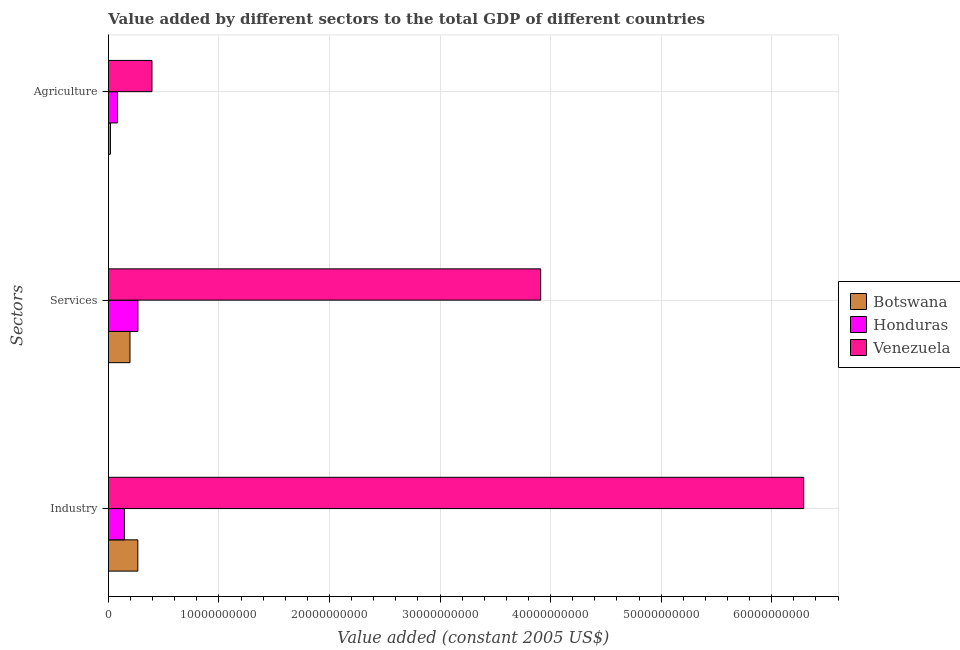How many different coloured bars are there?
Ensure brevity in your answer.  3. How many bars are there on the 2nd tick from the top?
Offer a terse response. 3. How many bars are there on the 3rd tick from the bottom?
Give a very brief answer. 3. What is the label of the 2nd group of bars from the top?
Provide a short and direct response. Services. What is the value added by services in Honduras?
Your response must be concise. 2.67e+09. Across all countries, what is the maximum value added by industrial sector?
Give a very brief answer. 6.29e+1. Across all countries, what is the minimum value added by services?
Ensure brevity in your answer.  1.95e+09. In which country was the value added by industrial sector maximum?
Your answer should be very brief. Venezuela. In which country was the value added by agricultural sector minimum?
Give a very brief answer. Botswana. What is the total value added by services in the graph?
Offer a very short reply. 4.37e+1. What is the difference between the value added by industrial sector in Venezuela and that in Botswana?
Your response must be concise. 6.02e+1. What is the difference between the value added by agricultural sector in Honduras and the value added by services in Venezuela?
Offer a terse response. -3.83e+1. What is the average value added by industrial sector per country?
Give a very brief answer. 2.23e+1. What is the difference between the value added by services and value added by industrial sector in Venezuela?
Provide a succinct answer. -2.38e+1. In how many countries, is the value added by services greater than 2000000000 US$?
Ensure brevity in your answer.  2. What is the ratio of the value added by industrial sector in Venezuela to that in Honduras?
Keep it short and to the point. 43.49. Is the value added by industrial sector in Botswana less than that in Venezuela?
Make the answer very short. Yes. What is the difference between the highest and the second highest value added by agricultural sector?
Provide a succinct answer. 3.12e+09. What is the difference between the highest and the lowest value added by agricultural sector?
Offer a terse response. 3.76e+09. Is the sum of the value added by services in Honduras and Venezuela greater than the maximum value added by agricultural sector across all countries?
Give a very brief answer. Yes. What does the 2nd bar from the top in Services represents?
Provide a succinct answer. Honduras. What does the 1st bar from the bottom in Industry represents?
Your answer should be very brief. Botswana. Are all the bars in the graph horizontal?
Provide a succinct answer. Yes. How many countries are there in the graph?
Give a very brief answer. 3. What is the difference between two consecutive major ticks on the X-axis?
Provide a short and direct response. 1.00e+1. Does the graph contain any zero values?
Your response must be concise. No. How many legend labels are there?
Your answer should be compact. 3. How are the legend labels stacked?
Keep it short and to the point. Vertical. What is the title of the graph?
Keep it short and to the point. Value added by different sectors to the total GDP of different countries. Does "Mongolia" appear as one of the legend labels in the graph?
Give a very brief answer. No. What is the label or title of the X-axis?
Keep it short and to the point. Value added (constant 2005 US$). What is the label or title of the Y-axis?
Your response must be concise. Sectors. What is the Value added (constant 2005 US$) in Botswana in Industry?
Your answer should be compact. 2.66e+09. What is the Value added (constant 2005 US$) of Honduras in Industry?
Your response must be concise. 1.45e+09. What is the Value added (constant 2005 US$) in Venezuela in Industry?
Give a very brief answer. 6.29e+1. What is the Value added (constant 2005 US$) of Botswana in Services?
Keep it short and to the point. 1.95e+09. What is the Value added (constant 2005 US$) of Honduras in Services?
Your answer should be compact. 2.67e+09. What is the Value added (constant 2005 US$) of Venezuela in Services?
Offer a very short reply. 3.91e+1. What is the Value added (constant 2005 US$) in Botswana in Agriculture?
Offer a very short reply. 1.83e+08. What is the Value added (constant 2005 US$) in Honduras in Agriculture?
Offer a terse response. 8.21e+08. What is the Value added (constant 2005 US$) in Venezuela in Agriculture?
Provide a short and direct response. 3.94e+09. Across all Sectors, what is the maximum Value added (constant 2005 US$) of Botswana?
Your answer should be compact. 2.66e+09. Across all Sectors, what is the maximum Value added (constant 2005 US$) of Honduras?
Offer a terse response. 2.67e+09. Across all Sectors, what is the maximum Value added (constant 2005 US$) in Venezuela?
Keep it short and to the point. 6.29e+1. Across all Sectors, what is the minimum Value added (constant 2005 US$) in Botswana?
Make the answer very short. 1.83e+08. Across all Sectors, what is the minimum Value added (constant 2005 US$) of Honduras?
Give a very brief answer. 8.21e+08. Across all Sectors, what is the minimum Value added (constant 2005 US$) in Venezuela?
Give a very brief answer. 3.94e+09. What is the total Value added (constant 2005 US$) of Botswana in the graph?
Provide a succinct answer. 4.79e+09. What is the total Value added (constant 2005 US$) in Honduras in the graph?
Offer a very short reply. 4.94e+09. What is the total Value added (constant 2005 US$) in Venezuela in the graph?
Your response must be concise. 1.06e+11. What is the difference between the Value added (constant 2005 US$) of Botswana in Industry and that in Services?
Give a very brief answer. 7.10e+08. What is the difference between the Value added (constant 2005 US$) in Honduras in Industry and that in Services?
Provide a short and direct response. -1.22e+09. What is the difference between the Value added (constant 2005 US$) in Venezuela in Industry and that in Services?
Give a very brief answer. 2.38e+1. What is the difference between the Value added (constant 2005 US$) of Botswana in Industry and that in Agriculture?
Your answer should be very brief. 2.48e+09. What is the difference between the Value added (constant 2005 US$) of Honduras in Industry and that in Agriculture?
Your answer should be very brief. 6.25e+08. What is the difference between the Value added (constant 2005 US$) of Venezuela in Industry and that in Agriculture?
Offer a very short reply. 5.90e+1. What is the difference between the Value added (constant 2005 US$) in Botswana in Services and that in Agriculture?
Your answer should be compact. 1.77e+09. What is the difference between the Value added (constant 2005 US$) of Honduras in Services and that in Agriculture?
Your answer should be compact. 1.85e+09. What is the difference between the Value added (constant 2005 US$) of Venezuela in Services and that in Agriculture?
Offer a very short reply. 3.52e+1. What is the difference between the Value added (constant 2005 US$) in Botswana in Industry and the Value added (constant 2005 US$) in Honduras in Services?
Offer a terse response. -8.78e+06. What is the difference between the Value added (constant 2005 US$) of Botswana in Industry and the Value added (constant 2005 US$) of Venezuela in Services?
Your answer should be compact. -3.64e+1. What is the difference between the Value added (constant 2005 US$) in Honduras in Industry and the Value added (constant 2005 US$) in Venezuela in Services?
Your answer should be compact. -3.77e+1. What is the difference between the Value added (constant 2005 US$) of Botswana in Industry and the Value added (constant 2005 US$) of Honduras in Agriculture?
Offer a terse response. 1.84e+09. What is the difference between the Value added (constant 2005 US$) in Botswana in Industry and the Value added (constant 2005 US$) in Venezuela in Agriculture?
Your answer should be compact. -1.28e+09. What is the difference between the Value added (constant 2005 US$) in Honduras in Industry and the Value added (constant 2005 US$) in Venezuela in Agriculture?
Ensure brevity in your answer.  -2.49e+09. What is the difference between the Value added (constant 2005 US$) in Botswana in Services and the Value added (constant 2005 US$) in Honduras in Agriculture?
Keep it short and to the point. 1.13e+09. What is the difference between the Value added (constant 2005 US$) in Botswana in Services and the Value added (constant 2005 US$) in Venezuela in Agriculture?
Your response must be concise. -1.99e+09. What is the difference between the Value added (constant 2005 US$) of Honduras in Services and the Value added (constant 2005 US$) of Venezuela in Agriculture?
Keep it short and to the point. -1.27e+09. What is the average Value added (constant 2005 US$) in Botswana per Sectors?
Make the answer very short. 1.60e+09. What is the average Value added (constant 2005 US$) in Honduras per Sectors?
Provide a succinct answer. 1.65e+09. What is the average Value added (constant 2005 US$) of Venezuela per Sectors?
Ensure brevity in your answer.  3.53e+1. What is the difference between the Value added (constant 2005 US$) in Botswana and Value added (constant 2005 US$) in Honduras in Industry?
Provide a succinct answer. 1.21e+09. What is the difference between the Value added (constant 2005 US$) in Botswana and Value added (constant 2005 US$) in Venezuela in Industry?
Offer a terse response. -6.02e+1. What is the difference between the Value added (constant 2005 US$) in Honduras and Value added (constant 2005 US$) in Venezuela in Industry?
Your answer should be compact. -6.14e+1. What is the difference between the Value added (constant 2005 US$) in Botswana and Value added (constant 2005 US$) in Honduras in Services?
Give a very brief answer. -7.19e+08. What is the difference between the Value added (constant 2005 US$) of Botswana and Value added (constant 2005 US$) of Venezuela in Services?
Keep it short and to the point. -3.72e+1. What is the difference between the Value added (constant 2005 US$) of Honduras and Value added (constant 2005 US$) of Venezuela in Services?
Your answer should be compact. -3.64e+1. What is the difference between the Value added (constant 2005 US$) in Botswana and Value added (constant 2005 US$) in Honduras in Agriculture?
Give a very brief answer. -6.38e+08. What is the difference between the Value added (constant 2005 US$) of Botswana and Value added (constant 2005 US$) of Venezuela in Agriculture?
Offer a very short reply. -3.76e+09. What is the difference between the Value added (constant 2005 US$) in Honduras and Value added (constant 2005 US$) in Venezuela in Agriculture?
Keep it short and to the point. -3.12e+09. What is the ratio of the Value added (constant 2005 US$) of Botswana in Industry to that in Services?
Give a very brief answer. 1.36. What is the ratio of the Value added (constant 2005 US$) in Honduras in Industry to that in Services?
Give a very brief answer. 0.54. What is the ratio of the Value added (constant 2005 US$) in Venezuela in Industry to that in Services?
Your response must be concise. 1.61. What is the ratio of the Value added (constant 2005 US$) of Botswana in Industry to that in Agriculture?
Offer a terse response. 14.55. What is the ratio of the Value added (constant 2005 US$) of Honduras in Industry to that in Agriculture?
Offer a terse response. 1.76. What is the ratio of the Value added (constant 2005 US$) in Venezuela in Industry to that in Agriculture?
Offer a terse response. 15.97. What is the ratio of the Value added (constant 2005 US$) in Botswana in Services to that in Agriculture?
Your answer should be compact. 10.66. What is the ratio of the Value added (constant 2005 US$) in Honduras in Services to that in Agriculture?
Provide a short and direct response. 3.25. What is the ratio of the Value added (constant 2005 US$) of Venezuela in Services to that in Agriculture?
Your answer should be compact. 9.93. What is the difference between the highest and the second highest Value added (constant 2005 US$) of Botswana?
Ensure brevity in your answer.  7.10e+08. What is the difference between the highest and the second highest Value added (constant 2005 US$) of Honduras?
Your answer should be very brief. 1.22e+09. What is the difference between the highest and the second highest Value added (constant 2005 US$) in Venezuela?
Make the answer very short. 2.38e+1. What is the difference between the highest and the lowest Value added (constant 2005 US$) in Botswana?
Offer a very short reply. 2.48e+09. What is the difference between the highest and the lowest Value added (constant 2005 US$) of Honduras?
Your response must be concise. 1.85e+09. What is the difference between the highest and the lowest Value added (constant 2005 US$) of Venezuela?
Provide a succinct answer. 5.90e+1. 